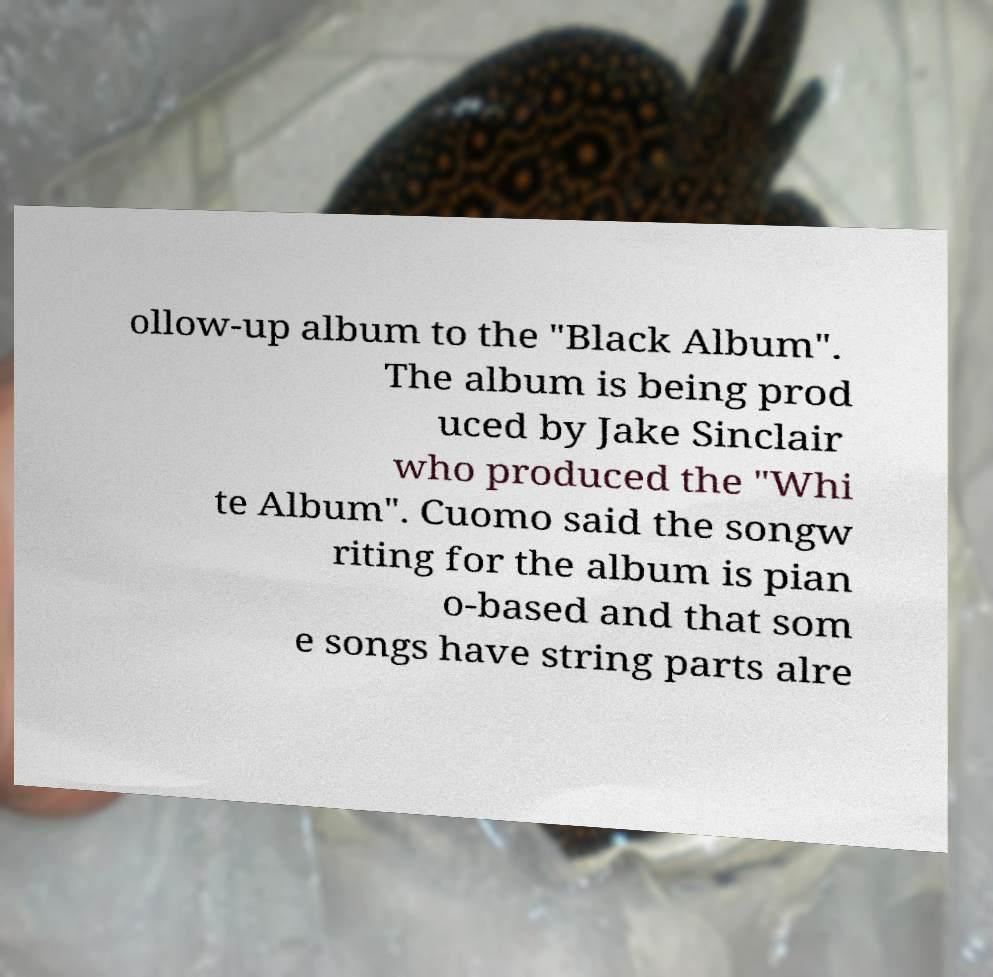Could you extract and type out the text from this image? ollow-up album to the "Black Album". The album is being prod uced by Jake Sinclair who produced the "Whi te Album". Cuomo said the songw riting for the album is pian o-based and that som e songs have string parts alre 